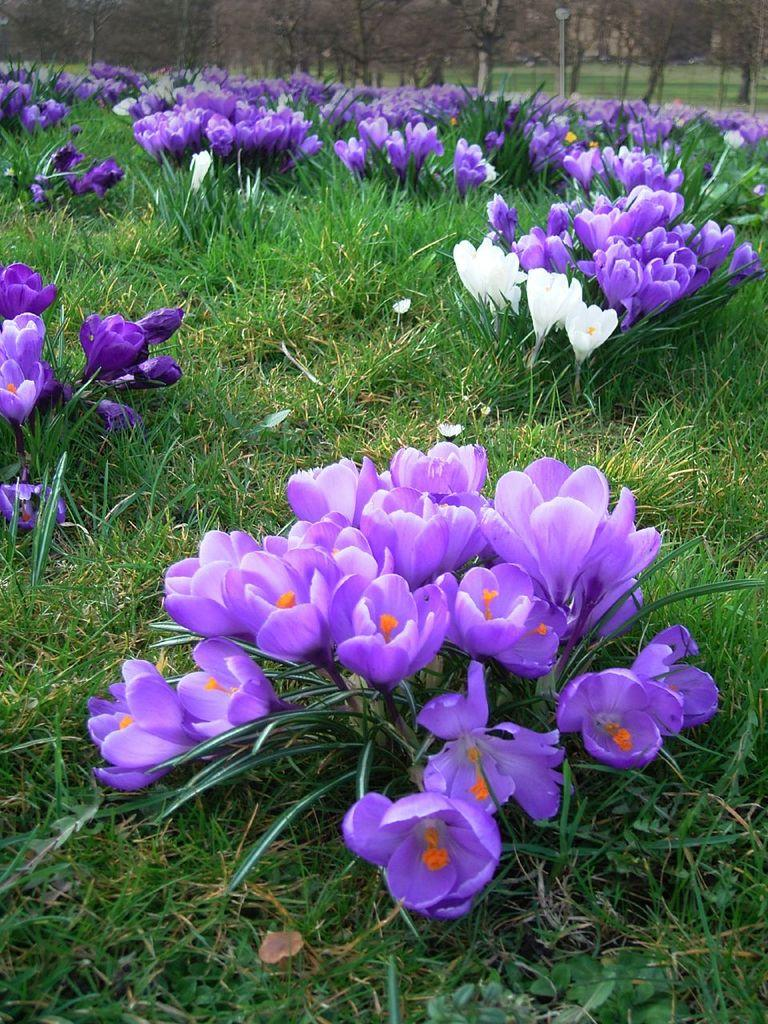What type of plants can be seen in the image? There are plants with flowers in the image. What type of vegetation is visible on the ground? There is grass visible in the image. What structure can be seen in the image? There is a pole in the image. What type of larger vegetation is present in the image? There is a group of trees in the image. What is the profit margin of the flowers in the image? There is no information about profit margins in the image, as it is a photograph of plants and not a financial document. 